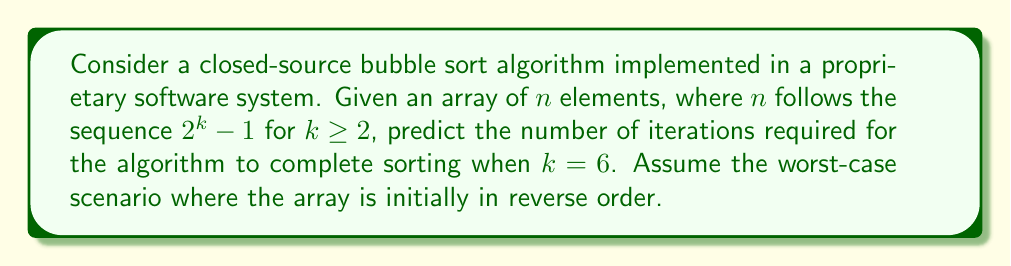Could you help me with this problem? Let's approach this step-by-step:

1) First, we need to determine the value of $n$ when $k = 6$:
   $n = 2^6 - 1 = 64 - 1 = 63$

2) In bubble sort, for an array of $n$ elements:
   - The outer loop runs $n-1$ times
   - In the worst case (reverse ordered array), the inner loop makes $\frac{n(n-1)}{2}$ comparisons

3) Therefore, the total number of iterations (comparisons) is:
   $\text{iterations} = \frac{n(n-1)}{2}$

4) Substituting $n = 63$:
   $\text{iterations} = \frac{63(63-1)}{2}$
   
5) Simplifying:
   $\text{iterations} = \frac{63 \times 62}{2} = \frac{3906}{2} = 1953$

Thus, the closed-source bubble sort algorithm will require 1953 iterations to complete sorting in this worst-case scenario.
Answer: 1953 